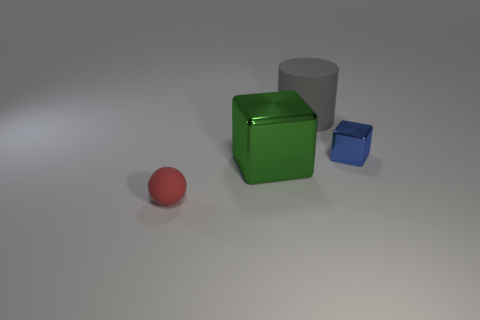There is a object that is both to the left of the blue metallic object and behind the green cube; what is its size?
Offer a very short reply. Large. There is another thing that is the same shape as the green thing; what material is it?
Keep it short and to the point. Metal. The small thing that is right of the tiny rubber sphere that is in front of the tiny block is made of what material?
Offer a terse response. Metal. There is a gray matte object; is its shape the same as the tiny thing that is in front of the green thing?
Offer a very short reply. No. What number of matte objects are either blue cubes or gray things?
Offer a very short reply. 1. What is the color of the matte object that is right of the matte thing that is in front of the metallic cube behind the big block?
Your answer should be compact. Gray. How many other objects are the same material as the cylinder?
Offer a terse response. 1. Is the shape of the shiny object that is to the right of the big metal cube the same as  the red object?
Your answer should be compact. No. How many small objects are gray objects or red objects?
Make the answer very short. 1. Are there an equal number of rubber cylinders to the left of the green shiny thing and large green shiny cubes to the right of the large cylinder?
Offer a very short reply. Yes. 